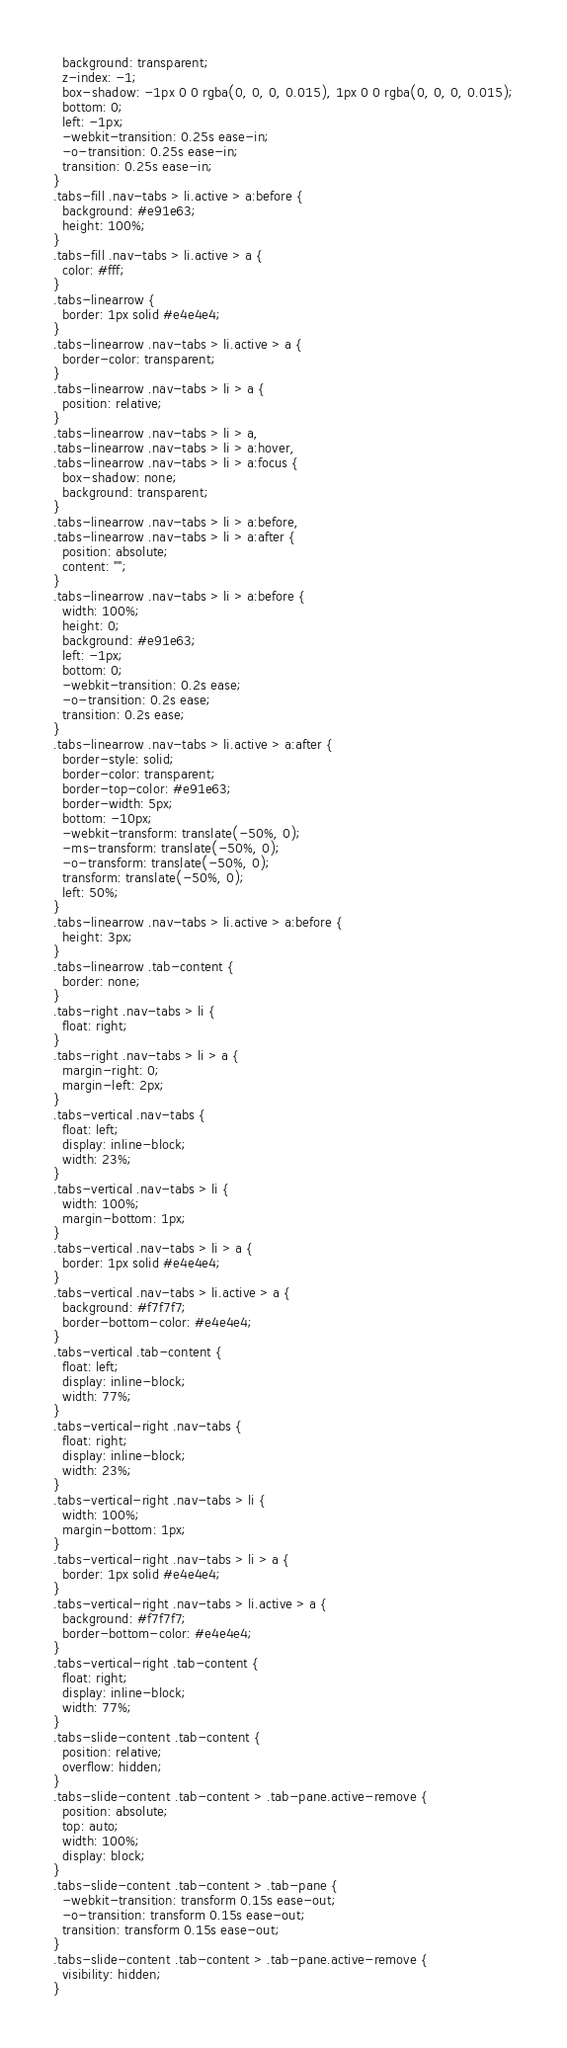<code> <loc_0><loc_0><loc_500><loc_500><_CSS_>  background: transparent;
  z-index: -1;
  box-shadow: -1px 0 0 rgba(0, 0, 0, 0.015), 1px 0 0 rgba(0, 0, 0, 0.015);
  bottom: 0;
  left: -1px;
  -webkit-transition: 0.25s ease-in;
  -o-transition: 0.25s ease-in;
  transition: 0.25s ease-in;
}
.tabs-fill .nav-tabs > li.active > a:before {
  background: #e91e63;
  height: 100%;
}
.tabs-fill .nav-tabs > li.active > a {
  color: #fff;
}
.tabs-linearrow {
  border: 1px solid #e4e4e4;
}
.tabs-linearrow .nav-tabs > li.active > a {
  border-color: transparent;
}
.tabs-linearrow .nav-tabs > li > a {
  position: relative;
}
.tabs-linearrow .nav-tabs > li > a,
.tabs-linearrow .nav-tabs > li > a:hover,
.tabs-linearrow .nav-tabs > li > a:focus {
  box-shadow: none;
  background: transparent;
}
.tabs-linearrow .nav-tabs > li > a:before,
.tabs-linearrow .nav-tabs > li > a:after {
  position: absolute;
  content: "";
}
.tabs-linearrow .nav-tabs > li > a:before {
  width: 100%;
  height: 0;
  background: #e91e63;
  left: -1px;
  bottom: 0;
  -webkit-transition: 0.2s ease;
  -o-transition: 0.2s ease;
  transition: 0.2s ease;
}
.tabs-linearrow .nav-tabs > li.active > a:after {
  border-style: solid;
  border-color: transparent;
  border-top-color: #e91e63;
  border-width: 5px;
  bottom: -10px;
  -webkit-transform: translate(-50%, 0);
  -ms-transform: translate(-50%, 0);
  -o-transform: translate(-50%, 0);
  transform: translate(-50%, 0);
  left: 50%;
}
.tabs-linearrow .nav-tabs > li.active > a:before {
  height: 3px;
}
.tabs-linearrow .tab-content {
  border: none;
}
.tabs-right .nav-tabs > li {
  float: right;
}
.tabs-right .nav-tabs > li > a {
  margin-right: 0;
  margin-left: 2px;
}
.tabs-vertical .nav-tabs {
  float: left;
  display: inline-block;
  width: 23%;
}
.tabs-vertical .nav-tabs > li {
  width: 100%;
  margin-bottom: 1px;
}
.tabs-vertical .nav-tabs > li > a {
  border: 1px solid #e4e4e4;
}
.tabs-vertical .nav-tabs > li.active > a {
  background: #f7f7f7;
  border-bottom-color: #e4e4e4;
}
.tabs-vertical .tab-content {
  float: left;
  display: inline-block;
  width: 77%;
}
.tabs-vertical-right .nav-tabs {
  float: right;
  display: inline-block;
  width: 23%;
}
.tabs-vertical-right .nav-tabs > li {
  width: 100%;
  margin-bottom: 1px;
}
.tabs-vertical-right .nav-tabs > li > a {
  border: 1px solid #e4e4e4;
}
.tabs-vertical-right .nav-tabs > li.active > a {
  background: #f7f7f7;
  border-bottom-color: #e4e4e4;
}
.tabs-vertical-right .tab-content {
  float: right;
  display: inline-block;
  width: 77%;
}
.tabs-slide-content .tab-content {
  position: relative;
  overflow: hidden;
}
.tabs-slide-content .tab-content > .tab-pane.active-remove {
  position: absolute;
  top: auto;
  width: 100%;
  display: block;
}
.tabs-slide-content .tab-content > .tab-pane {
  -webkit-transition: transform 0.15s ease-out;
  -o-transition: transform 0.15s ease-out;
  transition: transform 0.15s ease-out;
}
.tabs-slide-content .tab-content > .tab-pane.active-remove {
  visibility: hidden;
}</code> 